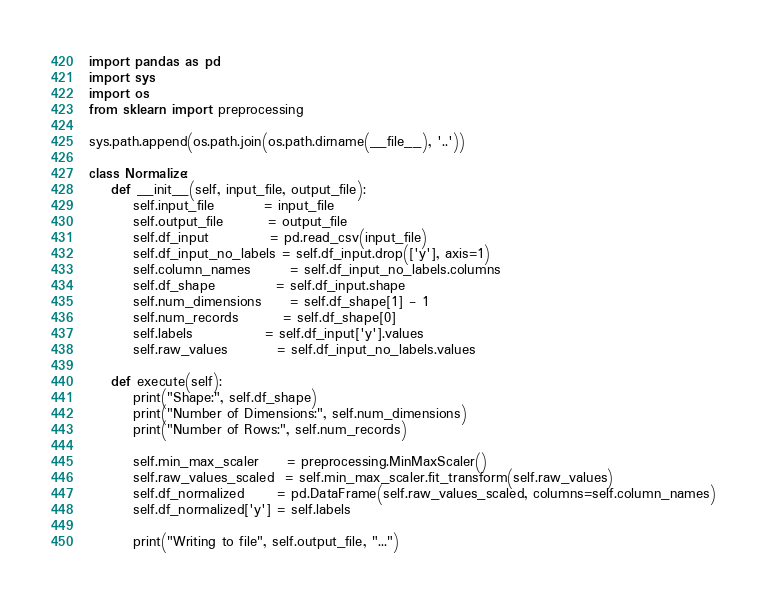Convert code to text. <code><loc_0><loc_0><loc_500><loc_500><_Python_>import pandas as pd
import sys
import os
from sklearn import preprocessing

sys.path.append(os.path.join(os.path.dirname(__file__), '..'))

class Normalize:
    def __init__(self, input_file, output_file):
        self.input_file         = input_file
        self.output_file        = output_file
        self.df_input           = pd.read_csv(input_file)
        self.df_input_no_labels = self.df_input.drop(['y'], axis=1)
        self.column_names       = self.df_input_no_labels.columns
        self.df_shape           = self.df_input.shape
        self.num_dimensions     = self.df_shape[1] - 1
        self.num_records        = self.df_shape[0]
        self.labels             = self.df_input['y'].values
        self.raw_values         = self.df_input_no_labels.values

    def execute(self):
        print("Shape:", self.df_shape)
        print("Number of Dimensions:", self.num_dimensions)
        print("Number of Rows:", self.num_records)

        self.min_max_scaler     = preprocessing.MinMaxScaler()
        self.raw_values_scaled  = self.min_max_scaler.fit_transform(self.raw_values)
        self.df_normalized      = pd.DataFrame(self.raw_values_scaled, columns=self.column_names)
        self.df_normalized['y'] = self.labels

        print("Writing to file", self.output_file, "...")</code> 